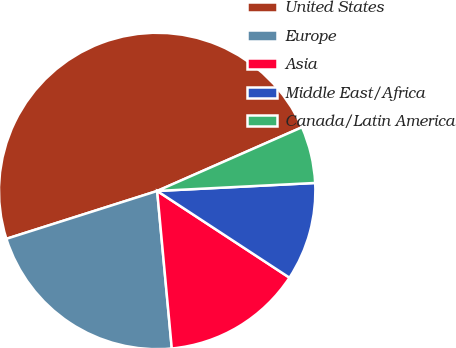Convert chart to OTSL. <chart><loc_0><loc_0><loc_500><loc_500><pie_chart><fcel>United States<fcel>Europe<fcel>Asia<fcel>Middle East/Africa<fcel>Canada/Latin America<nl><fcel>48.29%<fcel>21.58%<fcel>14.29%<fcel>10.04%<fcel>5.79%<nl></chart> 